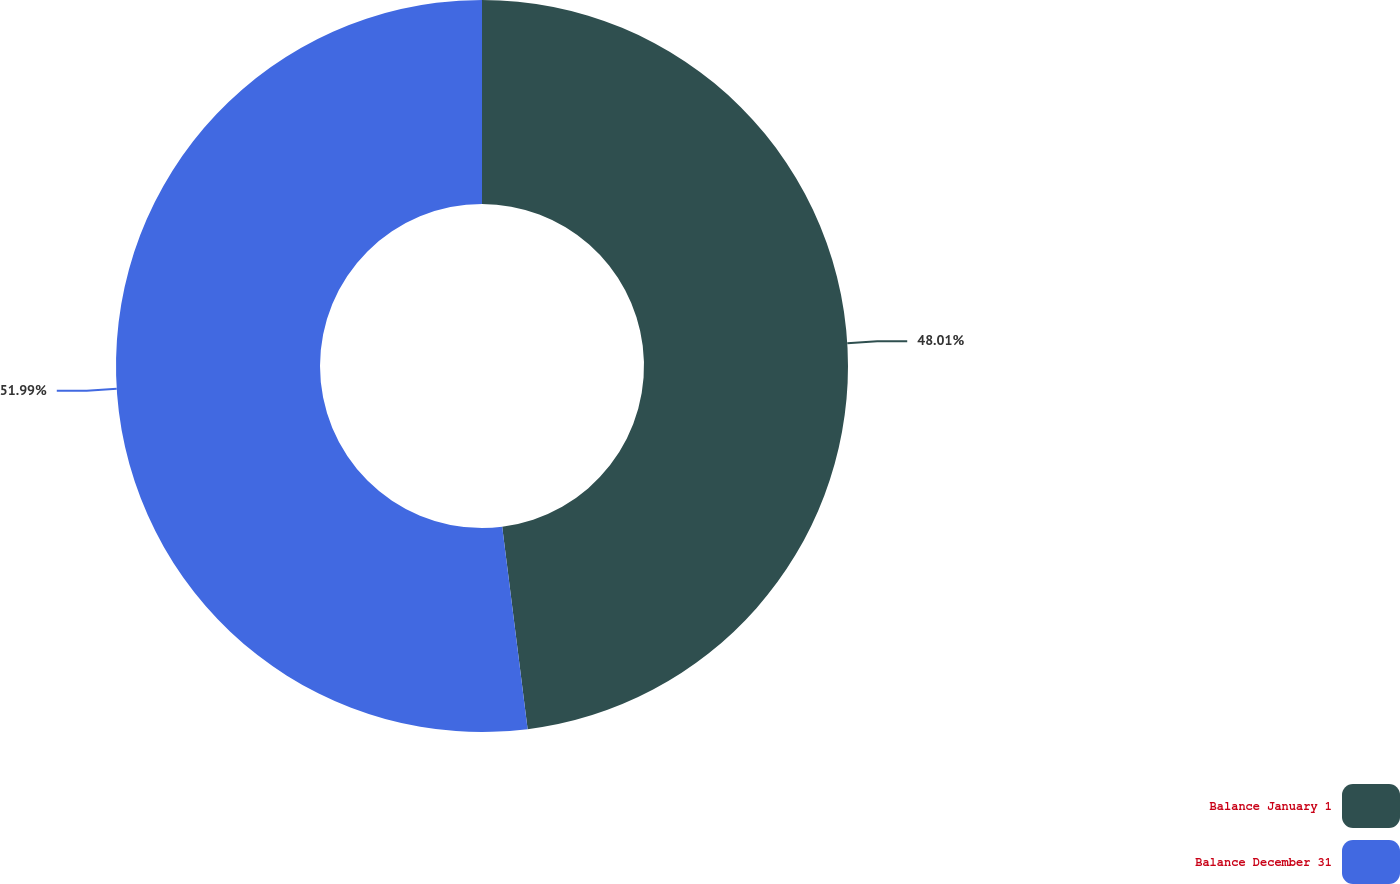<chart> <loc_0><loc_0><loc_500><loc_500><pie_chart><fcel>Balance January 1<fcel>Balance December 31<nl><fcel>48.01%<fcel>51.99%<nl></chart> 